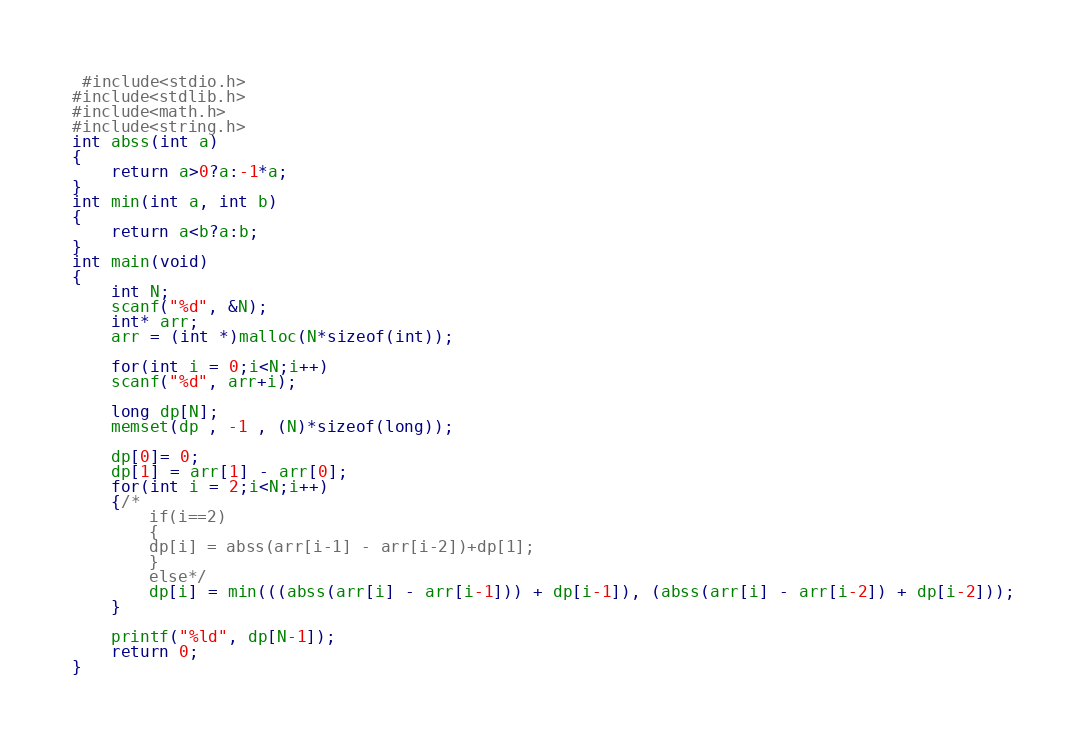Convert code to text. <code><loc_0><loc_0><loc_500><loc_500><_C_> #include<stdio.h>
#include<stdlib.h>
#include<math.h>
#include<string.h>
int abss(int a)
{
	return a>0?a:-1*a;
}
int min(int a, int b)
{
	return a<b?a:b;
}
int main(void)
{
	int N;
	scanf("%d", &N);
	int* arr;
	arr = (int *)malloc(N*sizeof(int));
	
	for(int i = 0;i<N;i++)
	scanf("%d", arr+i);
	
	long dp[N];
	memset(dp , -1 , (N)*sizeof(long));
	
	dp[0]= 0;
	dp[1] = arr[1] - arr[0];
	for(int i = 2;i<N;i++)
	{/*
		if(i==2)
		{
		dp[i] = abss(arr[i-1] - arr[i-2])+dp[1];
		}
		else*/
		dp[i] = min(((abss(arr[i] - arr[i-1])) + dp[i-1]), (abss(arr[i] - arr[i-2]) + dp[i-2]));
	}

	printf("%ld", dp[N-1]);
	return 0;
}
</code> 